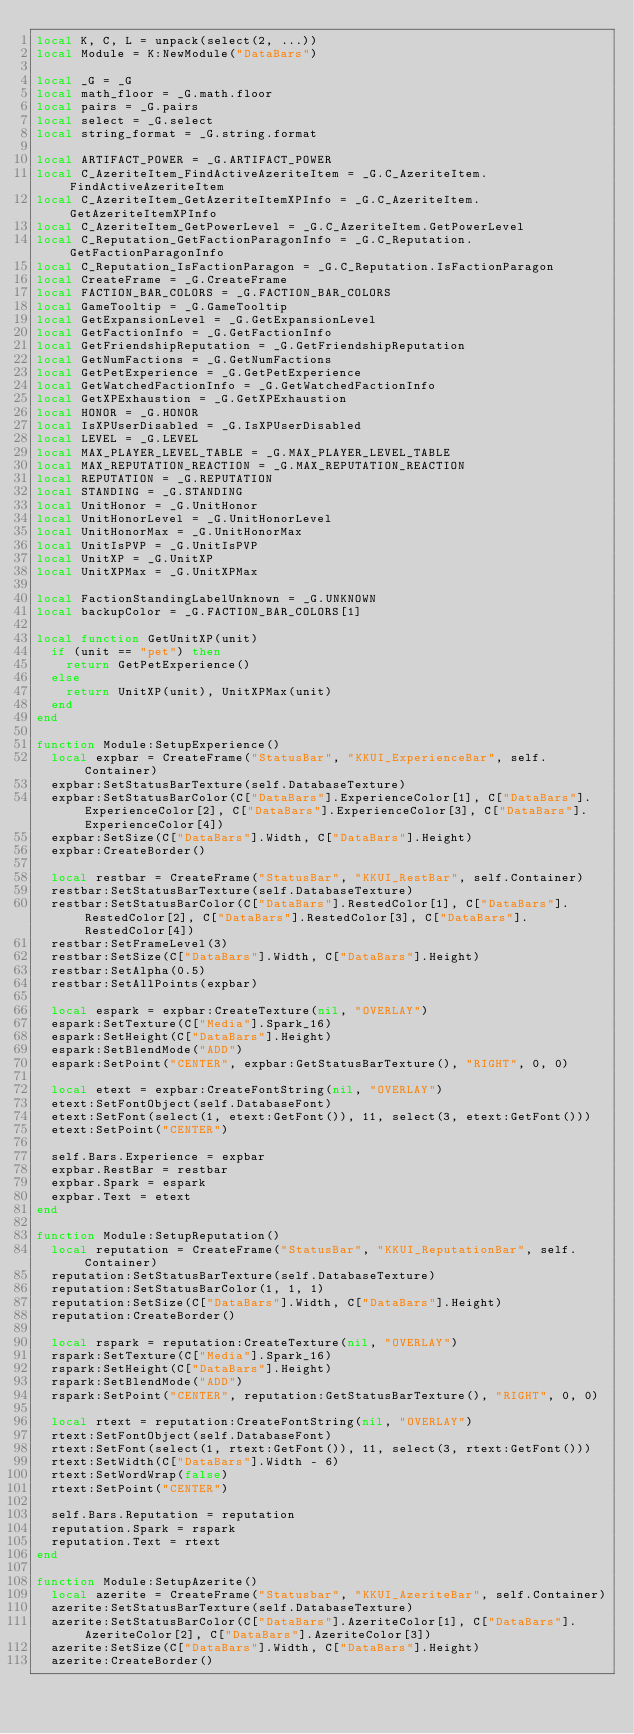Convert code to text. <code><loc_0><loc_0><loc_500><loc_500><_Lua_>local K, C, L = unpack(select(2, ...))
local Module = K:NewModule("DataBars")

local _G = _G
local math_floor = _G.math.floor
local pairs = _G.pairs
local select = _G.select
local string_format = _G.string.format

local ARTIFACT_POWER = _G.ARTIFACT_POWER
local C_AzeriteItem_FindActiveAzeriteItem = _G.C_AzeriteItem.FindActiveAzeriteItem
local C_AzeriteItem_GetAzeriteItemXPInfo = _G.C_AzeriteItem.GetAzeriteItemXPInfo
local C_AzeriteItem_GetPowerLevel = _G.C_AzeriteItem.GetPowerLevel
local C_Reputation_GetFactionParagonInfo = _G.C_Reputation.GetFactionParagonInfo
local C_Reputation_IsFactionParagon = _G.C_Reputation.IsFactionParagon
local CreateFrame = _G.CreateFrame
local FACTION_BAR_COLORS = _G.FACTION_BAR_COLORS
local GameTooltip = _G.GameTooltip
local GetExpansionLevel = _G.GetExpansionLevel
local GetFactionInfo = _G.GetFactionInfo
local GetFriendshipReputation = _G.GetFriendshipReputation
local GetNumFactions = _G.GetNumFactions
local GetPetExperience = _G.GetPetExperience
local GetWatchedFactionInfo = _G.GetWatchedFactionInfo
local GetXPExhaustion = _G.GetXPExhaustion
local HONOR = _G.HONOR
local IsXPUserDisabled = _G.IsXPUserDisabled
local LEVEL = _G.LEVEL
local MAX_PLAYER_LEVEL_TABLE = _G.MAX_PLAYER_LEVEL_TABLE
local MAX_REPUTATION_REACTION = _G.MAX_REPUTATION_REACTION
local REPUTATION = _G.REPUTATION
local STANDING = _G.STANDING
local UnitHonor = _G.UnitHonor
local UnitHonorLevel = _G.UnitHonorLevel
local UnitHonorMax = _G.UnitHonorMax
local UnitIsPVP = _G.UnitIsPVP
local UnitXP = _G.UnitXP
local UnitXPMax = _G.UnitXPMax

local FactionStandingLabelUnknown = _G.UNKNOWN
local backupColor = _G.FACTION_BAR_COLORS[1]

local function GetUnitXP(unit)
	if (unit == "pet") then
		return GetPetExperience()
	else
		return UnitXP(unit), UnitXPMax(unit)
	end
end

function Module:SetupExperience()
	local expbar = CreateFrame("StatusBar", "KKUI_ExperienceBar", self.Container)
	expbar:SetStatusBarTexture(self.DatabaseTexture)
	expbar:SetStatusBarColor(C["DataBars"].ExperienceColor[1], C["DataBars"].ExperienceColor[2], C["DataBars"].ExperienceColor[3], C["DataBars"].ExperienceColor[4])
	expbar:SetSize(C["DataBars"].Width, C["DataBars"].Height)
	expbar:CreateBorder()

	local restbar = CreateFrame("StatusBar", "KKUI_RestBar", self.Container)
	restbar:SetStatusBarTexture(self.DatabaseTexture)
	restbar:SetStatusBarColor(C["DataBars"].RestedColor[1], C["DataBars"].RestedColor[2], C["DataBars"].RestedColor[3], C["DataBars"].RestedColor[4])
	restbar:SetFrameLevel(3)
	restbar:SetSize(C["DataBars"].Width, C["DataBars"].Height)
	restbar:SetAlpha(0.5)
	restbar:SetAllPoints(expbar)

	local espark = expbar:CreateTexture(nil, "OVERLAY")
	espark:SetTexture(C["Media"].Spark_16)
	espark:SetHeight(C["DataBars"].Height)
	espark:SetBlendMode("ADD")
	espark:SetPoint("CENTER", expbar:GetStatusBarTexture(), "RIGHT", 0, 0)

	local etext = expbar:CreateFontString(nil, "OVERLAY")
	etext:SetFontObject(self.DatabaseFont)
	etext:SetFont(select(1, etext:GetFont()), 11, select(3, etext:GetFont()))
	etext:SetPoint("CENTER")

	self.Bars.Experience = expbar
	expbar.RestBar = restbar
	expbar.Spark = espark
	expbar.Text = etext
end

function Module:SetupReputation()
	local reputation = CreateFrame("StatusBar", "KKUI_ReputationBar", self.Container)
	reputation:SetStatusBarTexture(self.DatabaseTexture)
	reputation:SetStatusBarColor(1, 1, 1)
	reputation:SetSize(C["DataBars"].Width, C["DataBars"].Height)
	reputation:CreateBorder()

	local rspark = reputation:CreateTexture(nil, "OVERLAY")
	rspark:SetTexture(C["Media"].Spark_16)
	rspark:SetHeight(C["DataBars"].Height)
	rspark:SetBlendMode("ADD")
	rspark:SetPoint("CENTER", reputation:GetStatusBarTexture(), "RIGHT", 0, 0)

	local rtext = reputation:CreateFontString(nil, "OVERLAY")
	rtext:SetFontObject(self.DatabaseFont)
	rtext:SetFont(select(1, rtext:GetFont()), 11, select(3, rtext:GetFont()))
	rtext:SetWidth(C["DataBars"].Width - 6)
	rtext:SetWordWrap(false)
	rtext:SetPoint("CENTER")

	self.Bars.Reputation = reputation
	reputation.Spark = rspark
	reputation.Text = rtext
end

function Module:SetupAzerite()
	local azerite = CreateFrame("Statusbar", "KKUI_AzeriteBar", self.Container)
	azerite:SetStatusBarTexture(self.DatabaseTexture)
	azerite:SetStatusBarColor(C["DataBars"].AzeriteColor[1], C["DataBars"].AzeriteColor[2], C["DataBars"].AzeriteColor[3])
	azerite:SetSize(C["DataBars"].Width, C["DataBars"].Height)
	azerite:CreateBorder()
</code> 